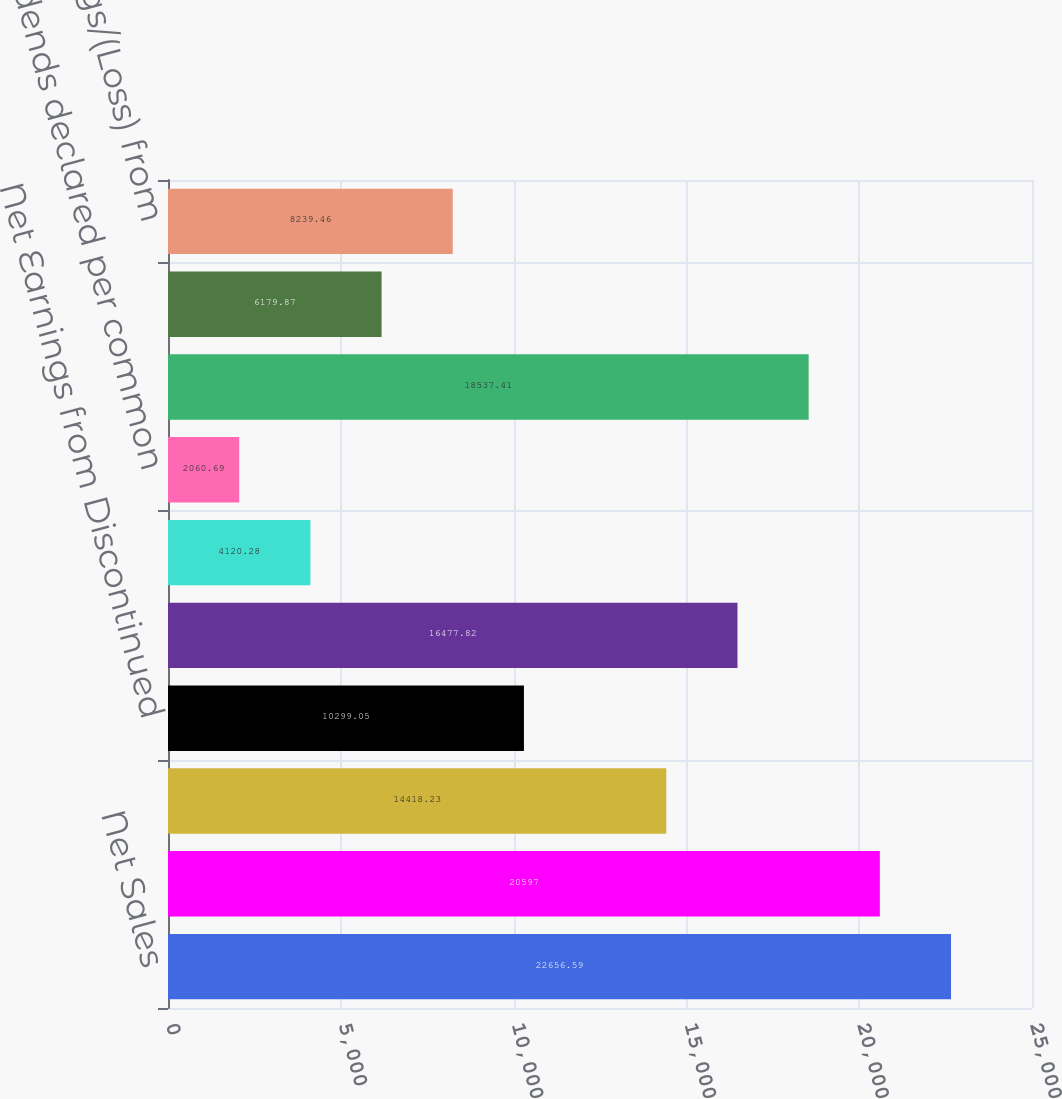Convert chart to OTSL. <chart><loc_0><loc_0><loc_500><loc_500><bar_chart><fcel>Net Sales<fcel>Gross Margin<fcel>Net Earnings from Continuing<fcel>Net Earnings from Discontinued<fcel>Net Earnings<fcel>Net Earnings per common share<fcel>Dividends declared per common<fcel>Cash and cash equivalents<fcel>Marketable securities<fcel>Net Earnings/(Loss) from<nl><fcel>22656.6<fcel>20597<fcel>14418.2<fcel>10299<fcel>16477.8<fcel>4120.28<fcel>2060.69<fcel>18537.4<fcel>6179.87<fcel>8239.46<nl></chart> 